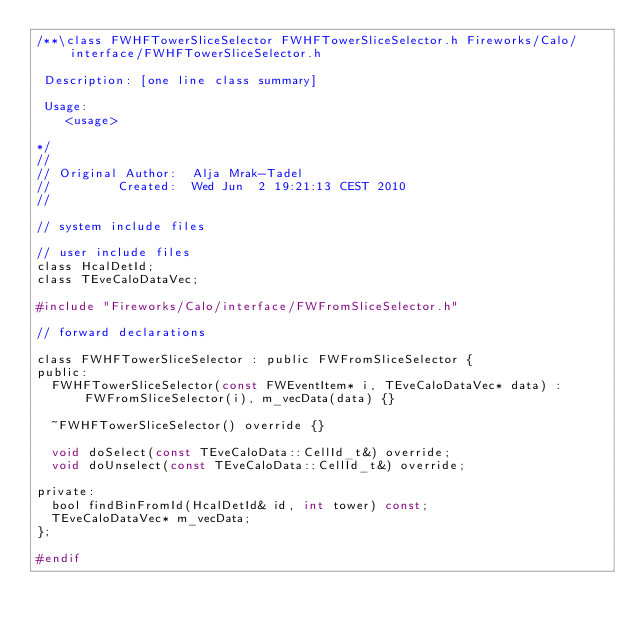Convert code to text. <code><loc_0><loc_0><loc_500><loc_500><_C_>/**\class FWHFTowerSliceSelector FWHFTowerSliceSelector.h Fireworks/Calo/interface/FWHFTowerSliceSelector.h

 Description: [one line class summary]

 Usage:
    <usage>

*/
//
// Original Author:  Alja Mrak-Tadel
//         Created:  Wed Jun  2 19:21:13 CEST 2010
//

// system include files

// user include files
class HcalDetId;
class TEveCaloDataVec;

#include "Fireworks/Calo/interface/FWFromSliceSelector.h"

// forward declarations

class FWHFTowerSliceSelector : public FWFromSliceSelector {
public:
  FWHFTowerSliceSelector(const FWEventItem* i, TEveCaloDataVec* data) : FWFromSliceSelector(i), m_vecData(data) {}

  ~FWHFTowerSliceSelector() override {}

  void doSelect(const TEveCaloData::CellId_t&) override;
  void doUnselect(const TEveCaloData::CellId_t&) override;

private:
  bool findBinFromId(HcalDetId& id, int tower) const;
  TEveCaloDataVec* m_vecData;
};

#endif
</code> 